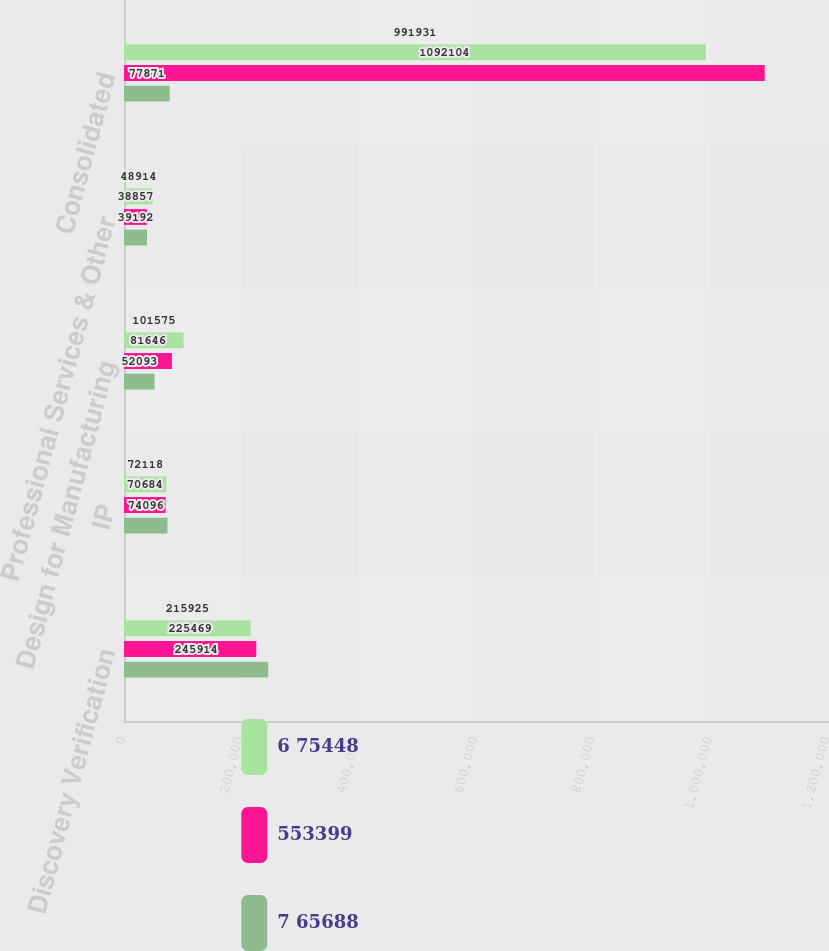<chart> <loc_0><loc_0><loc_500><loc_500><stacked_bar_chart><ecel><fcel>Discovery Verification<fcel>IP<fcel>Design for Manufacturing<fcel>Professional Services & Other<fcel>Consolidated<nl><fcel>6 75448<fcel>215925<fcel>72118<fcel>101575<fcel>48914<fcel>991931<nl><fcel>553399<fcel>225469<fcel>70684<fcel>81646<fcel>38857<fcel>1.0921e+06<nl><fcel>7 65688<fcel>245914<fcel>74096<fcel>52093<fcel>39192<fcel>77871<nl></chart> 